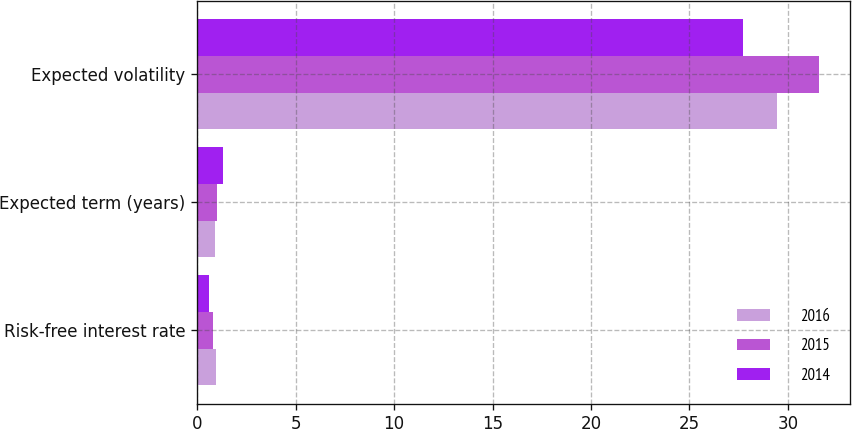Convert chart to OTSL. <chart><loc_0><loc_0><loc_500><loc_500><stacked_bar_chart><ecel><fcel>Risk-free interest rate<fcel>Expected term (years)<fcel>Expected volatility<nl><fcel>2016<fcel>0.95<fcel>0.9<fcel>29.46<nl><fcel>2015<fcel>0.83<fcel>1<fcel>31.59<nl><fcel>2014<fcel>0.59<fcel>1.3<fcel>27.72<nl></chart> 